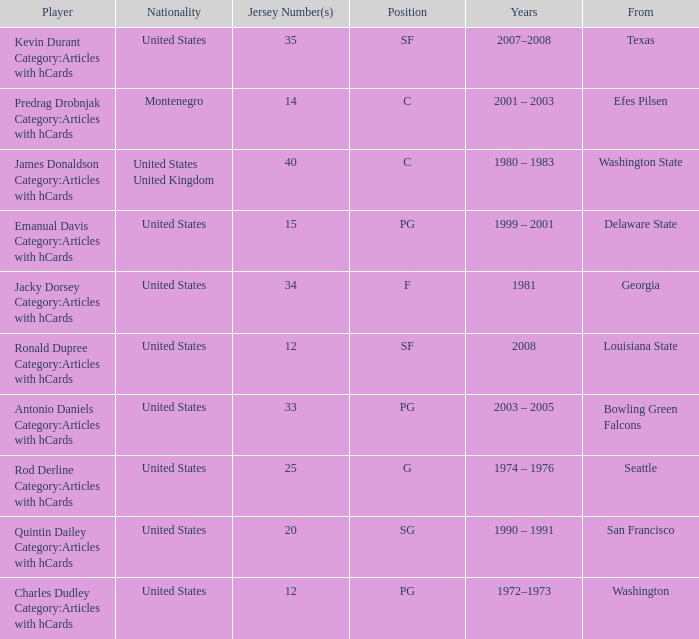What college was the player with the jersey number of 34 from? Georgia. 